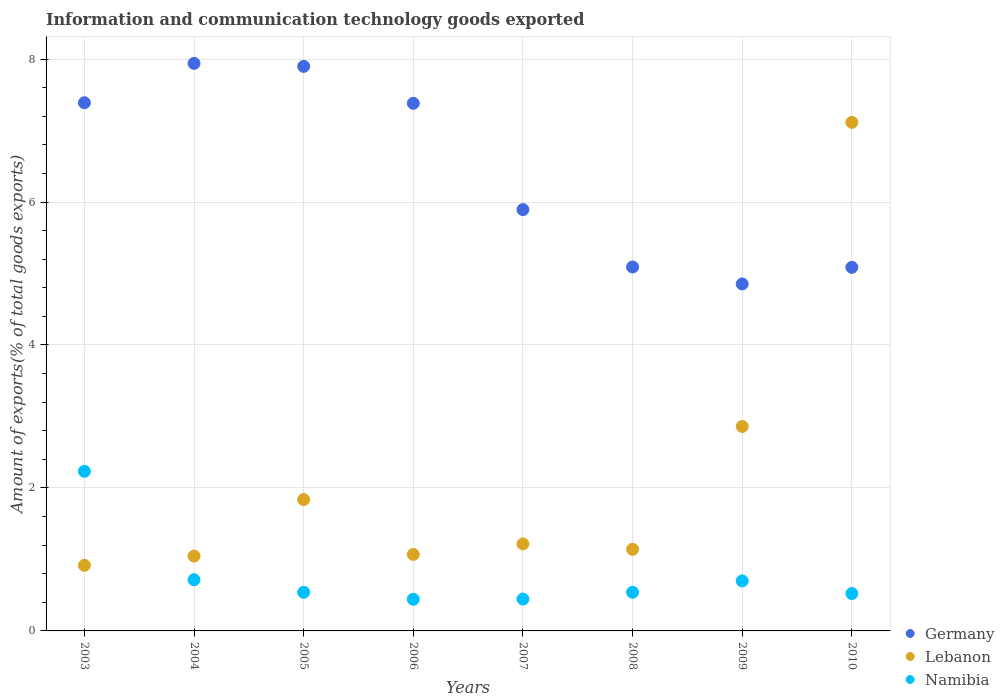What is the amount of goods exported in Germany in 2004?
Give a very brief answer. 7.94. Across all years, what is the maximum amount of goods exported in Lebanon?
Your response must be concise. 7.11. Across all years, what is the minimum amount of goods exported in Lebanon?
Ensure brevity in your answer.  0.92. What is the total amount of goods exported in Lebanon in the graph?
Offer a very short reply. 17.2. What is the difference between the amount of goods exported in Germany in 2004 and that in 2007?
Your answer should be very brief. 2.05. What is the difference between the amount of goods exported in Lebanon in 2006 and the amount of goods exported in Germany in 2005?
Your response must be concise. -6.83. What is the average amount of goods exported in Germany per year?
Keep it short and to the point. 6.44. In the year 2003, what is the difference between the amount of goods exported in Namibia and amount of goods exported in Germany?
Offer a very short reply. -5.16. What is the ratio of the amount of goods exported in Germany in 2004 to that in 2008?
Your answer should be very brief. 1.56. Is the difference between the amount of goods exported in Namibia in 2004 and 2007 greater than the difference between the amount of goods exported in Germany in 2004 and 2007?
Your response must be concise. No. What is the difference between the highest and the second highest amount of goods exported in Germany?
Your answer should be compact. 0.04. What is the difference between the highest and the lowest amount of goods exported in Namibia?
Offer a terse response. 1.79. Is the sum of the amount of goods exported in Lebanon in 2007 and 2010 greater than the maximum amount of goods exported in Germany across all years?
Make the answer very short. Yes. Is it the case that in every year, the sum of the amount of goods exported in Lebanon and amount of goods exported in Germany  is greater than the amount of goods exported in Namibia?
Your response must be concise. Yes. Does the amount of goods exported in Lebanon monotonically increase over the years?
Make the answer very short. No. Is the amount of goods exported in Germany strictly greater than the amount of goods exported in Namibia over the years?
Give a very brief answer. Yes. Is the amount of goods exported in Germany strictly less than the amount of goods exported in Namibia over the years?
Make the answer very short. No. How many years are there in the graph?
Offer a very short reply. 8. What is the difference between two consecutive major ticks on the Y-axis?
Offer a terse response. 2. Are the values on the major ticks of Y-axis written in scientific E-notation?
Your answer should be compact. No. Does the graph contain any zero values?
Give a very brief answer. No. Does the graph contain grids?
Your answer should be very brief. Yes. Where does the legend appear in the graph?
Give a very brief answer. Bottom right. How are the legend labels stacked?
Offer a terse response. Vertical. What is the title of the graph?
Your answer should be compact. Information and communication technology goods exported. Does "Belarus" appear as one of the legend labels in the graph?
Keep it short and to the point. No. What is the label or title of the Y-axis?
Offer a very short reply. Amount of exports(% of total goods exports). What is the Amount of exports(% of total goods exports) in Germany in 2003?
Your answer should be compact. 7.39. What is the Amount of exports(% of total goods exports) in Lebanon in 2003?
Your answer should be very brief. 0.92. What is the Amount of exports(% of total goods exports) of Namibia in 2003?
Keep it short and to the point. 2.23. What is the Amount of exports(% of total goods exports) of Germany in 2004?
Offer a terse response. 7.94. What is the Amount of exports(% of total goods exports) in Lebanon in 2004?
Your response must be concise. 1.05. What is the Amount of exports(% of total goods exports) of Namibia in 2004?
Ensure brevity in your answer.  0.72. What is the Amount of exports(% of total goods exports) in Germany in 2005?
Provide a succinct answer. 7.9. What is the Amount of exports(% of total goods exports) of Lebanon in 2005?
Your answer should be compact. 1.84. What is the Amount of exports(% of total goods exports) in Namibia in 2005?
Offer a very short reply. 0.54. What is the Amount of exports(% of total goods exports) of Germany in 2006?
Make the answer very short. 7.38. What is the Amount of exports(% of total goods exports) of Lebanon in 2006?
Offer a very short reply. 1.07. What is the Amount of exports(% of total goods exports) of Namibia in 2006?
Provide a succinct answer. 0.44. What is the Amount of exports(% of total goods exports) of Germany in 2007?
Keep it short and to the point. 5.89. What is the Amount of exports(% of total goods exports) in Lebanon in 2007?
Provide a short and direct response. 1.22. What is the Amount of exports(% of total goods exports) of Namibia in 2007?
Provide a succinct answer. 0.45. What is the Amount of exports(% of total goods exports) in Germany in 2008?
Offer a very short reply. 5.09. What is the Amount of exports(% of total goods exports) of Lebanon in 2008?
Offer a terse response. 1.14. What is the Amount of exports(% of total goods exports) in Namibia in 2008?
Provide a succinct answer. 0.54. What is the Amount of exports(% of total goods exports) of Germany in 2009?
Your answer should be compact. 4.85. What is the Amount of exports(% of total goods exports) in Lebanon in 2009?
Your response must be concise. 2.86. What is the Amount of exports(% of total goods exports) in Namibia in 2009?
Give a very brief answer. 0.7. What is the Amount of exports(% of total goods exports) in Germany in 2010?
Offer a very short reply. 5.09. What is the Amount of exports(% of total goods exports) in Lebanon in 2010?
Offer a very short reply. 7.11. What is the Amount of exports(% of total goods exports) in Namibia in 2010?
Your answer should be compact. 0.52. Across all years, what is the maximum Amount of exports(% of total goods exports) of Germany?
Offer a very short reply. 7.94. Across all years, what is the maximum Amount of exports(% of total goods exports) in Lebanon?
Keep it short and to the point. 7.11. Across all years, what is the maximum Amount of exports(% of total goods exports) of Namibia?
Offer a very short reply. 2.23. Across all years, what is the minimum Amount of exports(% of total goods exports) of Germany?
Your response must be concise. 4.85. Across all years, what is the minimum Amount of exports(% of total goods exports) of Lebanon?
Your answer should be compact. 0.92. Across all years, what is the minimum Amount of exports(% of total goods exports) in Namibia?
Your response must be concise. 0.44. What is the total Amount of exports(% of total goods exports) of Germany in the graph?
Your response must be concise. 51.53. What is the total Amount of exports(% of total goods exports) of Lebanon in the graph?
Give a very brief answer. 17.2. What is the total Amount of exports(% of total goods exports) in Namibia in the graph?
Your answer should be very brief. 6.14. What is the difference between the Amount of exports(% of total goods exports) in Germany in 2003 and that in 2004?
Your response must be concise. -0.55. What is the difference between the Amount of exports(% of total goods exports) in Lebanon in 2003 and that in 2004?
Your response must be concise. -0.13. What is the difference between the Amount of exports(% of total goods exports) in Namibia in 2003 and that in 2004?
Provide a succinct answer. 1.52. What is the difference between the Amount of exports(% of total goods exports) of Germany in 2003 and that in 2005?
Keep it short and to the point. -0.51. What is the difference between the Amount of exports(% of total goods exports) of Lebanon in 2003 and that in 2005?
Your response must be concise. -0.92. What is the difference between the Amount of exports(% of total goods exports) in Namibia in 2003 and that in 2005?
Your response must be concise. 1.69. What is the difference between the Amount of exports(% of total goods exports) of Germany in 2003 and that in 2006?
Make the answer very short. 0.01. What is the difference between the Amount of exports(% of total goods exports) of Lebanon in 2003 and that in 2006?
Your answer should be very brief. -0.15. What is the difference between the Amount of exports(% of total goods exports) in Namibia in 2003 and that in 2006?
Keep it short and to the point. 1.79. What is the difference between the Amount of exports(% of total goods exports) of Germany in 2003 and that in 2007?
Ensure brevity in your answer.  1.49. What is the difference between the Amount of exports(% of total goods exports) of Lebanon in 2003 and that in 2007?
Provide a succinct answer. -0.3. What is the difference between the Amount of exports(% of total goods exports) in Namibia in 2003 and that in 2007?
Your answer should be compact. 1.79. What is the difference between the Amount of exports(% of total goods exports) of Germany in 2003 and that in 2008?
Ensure brevity in your answer.  2.3. What is the difference between the Amount of exports(% of total goods exports) in Lebanon in 2003 and that in 2008?
Provide a short and direct response. -0.22. What is the difference between the Amount of exports(% of total goods exports) in Namibia in 2003 and that in 2008?
Your response must be concise. 1.69. What is the difference between the Amount of exports(% of total goods exports) in Germany in 2003 and that in 2009?
Make the answer very short. 2.53. What is the difference between the Amount of exports(% of total goods exports) in Lebanon in 2003 and that in 2009?
Offer a terse response. -1.94. What is the difference between the Amount of exports(% of total goods exports) of Namibia in 2003 and that in 2009?
Your answer should be compact. 1.53. What is the difference between the Amount of exports(% of total goods exports) of Germany in 2003 and that in 2010?
Provide a succinct answer. 2.3. What is the difference between the Amount of exports(% of total goods exports) of Lebanon in 2003 and that in 2010?
Provide a short and direct response. -6.2. What is the difference between the Amount of exports(% of total goods exports) in Namibia in 2003 and that in 2010?
Provide a succinct answer. 1.71. What is the difference between the Amount of exports(% of total goods exports) of Germany in 2004 and that in 2005?
Ensure brevity in your answer.  0.04. What is the difference between the Amount of exports(% of total goods exports) of Lebanon in 2004 and that in 2005?
Your answer should be compact. -0.79. What is the difference between the Amount of exports(% of total goods exports) of Namibia in 2004 and that in 2005?
Your answer should be compact. 0.18. What is the difference between the Amount of exports(% of total goods exports) of Germany in 2004 and that in 2006?
Your answer should be compact. 0.56. What is the difference between the Amount of exports(% of total goods exports) of Lebanon in 2004 and that in 2006?
Your answer should be compact. -0.02. What is the difference between the Amount of exports(% of total goods exports) in Namibia in 2004 and that in 2006?
Give a very brief answer. 0.27. What is the difference between the Amount of exports(% of total goods exports) of Germany in 2004 and that in 2007?
Ensure brevity in your answer.  2.05. What is the difference between the Amount of exports(% of total goods exports) of Lebanon in 2004 and that in 2007?
Make the answer very short. -0.17. What is the difference between the Amount of exports(% of total goods exports) in Namibia in 2004 and that in 2007?
Your response must be concise. 0.27. What is the difference between the Amount of exports(% of total goods exports) of Germany in 2004 and that in 2008?
Keep it short and to the point. 2.85. What is the difference between the Amount of exports(% of total goods exports) of Lebanon in 2004 and that in 2008?
Ensure brevity in your answer.  -0.09. What is the difference between the Amount of exports(% of total goods exports) in Namibia in 2004 and that in 2008?
Offer a terse response. 0.17. What is the difference between the Amount of exports(% of total goods exports) of Germany in 2004 and that in 2009?
Your response must be concise. 3.09. What is the difference between the Amount of exports(% of total goods exports) of Lebanon in 2004 and that in 2009?
Offer a very short reply. -1.81. What is the difference between the Amount of exports(% of total goods exports) in Namibia in 2004 and that in 2009?
Your answer should be compact. 0.02. What is the difference between the Amount of exports(% of total goods exports) of Germany in 2004 and that in 2010?
Your response must be concise. 2.85. What is the difference between the Amount of exports(% of total goods exports) in Lebanon in 2004 and that in 2010?
Make the answer very short. -6.07. What is the difference between the Amount of exports(% of total goods exports) in Namibia in 2004 and that in 2010?
Provide a succinct answer. 0.19. What is the difference between the Amount of exports(% of total goods exports) of Germany in 2005 and that in 2006?
Make the answer very short. 0.52. What is the difference between the Amount of exports(% of total goods exports) in Lebanon in 2005 and that in 2006?
Give a very brief answer. 0.77. What is the difference between the Amount of exports(% of total goods exports) of Namibia in 2005 and that in 2006?
Provide a succinct answer. 0.1. What is the difference between the Amount of exports(% of total goods exports) of Germany in 2005 and that in 2007?
Make the answer very short. 2. What is the difference between the Amount of exports(% of total goods exports) of Lebanon in 2005 and that in 2007?
Ensure brevity in your answer.  0.62. What is the difference between the Amount of exports(% of total goods exports) in Namibia in 2005 and that in 2007?
Your response must be concise. 0.09. What is the difference between the Amount of exports(% of total goods exports) of Germany in 2005 and that in 2008?
Ensure brevity in your answer.  2.81. What is the difference between the Amount of exports(% of total goods exports) of Lebanon in 2005 and that in 2008?
Provide a short and direct response. 0.7. What is the difference between the Amount of exports(% of total goods exports) in Namibia in 2005 and that in 2008?
Provide a short and direct response. -0. What is the difference between the Amount of exports(% of total goods exports) of Germany in 2005 and that in 2009?
Make the answer very short. 3.04. What is the difference between the Amount of exports(% of total goods exports) of Lebanon in 2005 and that in 2009?
Offer a very short reply. -1.02. What is the difference between the Amount of exports(% of total goods exports) of Namibia in 2005 and that in 2009?
Give a very brief answer. -0.16. What is the difference between the Amount of exports(% of total goods exports) of Germany in 2005 and that in 2010?
Your response must be concise. 2.81. What is the difference between the Amount of exports(% of total goods exports) in Lebanon in 2005 and that in 2010?
Make the answer very short. -5.28. What is the difference between the Amount of exports(% of total goods exports) of Namibia in 2005 and that in 2010?
Your response must be concise. 0.02. What is the difference between the Amount of exports(% of total goods exports) in Germany in 2006 and that in 2007?
Keep it short and to the point. 1.49. What is the difference between the Amount of exports(% of total goods exports) of Lebanon in 2006 and that in 2007?
Offer a terse response. -0.15. What is the difference between the Amount of exports(% of total goods exports) of Namibia in 2006 and that in 2007?
Provide a succinct answer. -0. What is the difference between the Amount of exports(% of total goods exports) of Germany in 2006 and that in 2008?
Provide a succinct answer. 2.29. What is the difference between the Amount of exports(% of total goods exports) in Lebanon in 2006 and that in 2008?
Provide a short and direct response. -0.07. What is the difference between the Amount of exports(% of total goods exports) of Namibia in 2006 and that in 2008?
Offer a terse response. -0.1. What is the difference between the Amount of exports(% of total goods exports) of Germany in 2006 and that in 2009?
Make the answer very short. 2.53. What is the difference between the Amount of exports(% of total goods exports) in Lebanon in 2006 and that in 2009?
Offer a terse response. -1.79. What is the difference between the Amount of exports(% of total goods exports) of Namibia in 2006 and that in 2009?
Provide a succinct answer. -0.26. What is the difference between the Amount of exports(% of total goods exports) of Germany in 2006 and that in 2010?
Your response must be concise. 2.29. What is the difference between the Amount of exports(% of total goods exports) in Lebanon in 2006 and that in 2010?
Ensure brevity in your answer.  -6.04. What is the difference between the Amount of exports(% of total goods exports) of Namibia in 2006 and that in 2010?
Make the answer very short. -0.08. What is the difference between the Amount of exports(% of total goods exports) in Germany in 2007 and that in 2008?
Your answer should be compact. 0.8. What is the difference between the Amount of exports(% of total goods exports) of Lebanon in 2007 and that in 2008?
Your response must be concise. 0.08. What is the difference between the Amount of exports(% of total goods exports) of Namibia in 2007 and that in 2008?
Offer a terse response. -0.1. What is the difference between the Amount of exports(% of total goods exports) in Lebanon in 2007 and that in 2009?
Offer a terse response. -1.64. What is the difference between the Amount of exports(% of total goods exports) in Namibia in 2007 and that in 2009?
Make the answer very short. -0.25. What is the difference between the Amount of exports(% of total goods exports) in Germany in 2007 and that in 2010?
Your answer should be very brief. 0.81. What is the difference between the Amount of exports(% of total goods exports) in Lebanon in 2007 and that in 2010?
Your response must be concise. -5.9. What is the difference between the Amount of exports(% of total goods exports) of Namibia in 2007 and that in 2010?
Your response must be concise. -0.08. What is the difference between the Amount of exports(% of total goods exports) in Germany in 2008 and that in 2009?
Your answer should be compact. 0.24. What is the difference between the Amount of exports(% of total goods exports) of Lebanon in 2008 and that in 2009?
Your response must be concise. -1.72. What is the difference between the Amount of exports(% of total goods exports) of Namibia in 2008 and that in 2009?
Give a very brief answer. -0.16. What is the difference between the Amount of exports(% of total goods exports) in Germany in 2008 and that in 2010?
Your answer should be very brief. 0. What is the difference between the Amount of exports(% of total goods exports) of Lebanon in 2008 and that in 2010?
Give a very brief answer. -5.97. What is the difference between the Amount of exports(% of total goods exports) of Namibia in 2008 and that in 2010?
Make the answer very short. 0.02. What is the difference between the Amount of exports(% of total goods exports) of Germany in 2009 and that in 2010?
Provide a short and direct response. -0.23. What is the difference between the Amount of exports(% of total goods exports) in Lebanon in 2009 and that in 2010?
Offer a very short reply. -4.25. What is the difference between the Amount of exports(% of total goods exports) of Namibia in 2009 and that in 2010?
Make the answer very short. 0.18. What is the difference between the Amount of exports(% of total goods exports) of Germany in 2003 and the Amount of exports(% of total goods exports) of Lebanon in 2004?
Your answer should be compact. 6.34. What is the difference between the Amount of exports(% of total goods exports) of Germany in 2003 and the Amount of exports(% of total goods exports) of Namibia in 2004?
Ensure brevity in your answer.  6.67. What is the difference between the Amount of exports(% of total goods exports) in Lebanon in 2003 and the Amount of exports(% of total goods exports) in Namibia in 2004?
Offer a terse response. 0.2. What is the difference between the Amount of exports(% of total goods exports) in Germany in 2003 and the Amount of exports(% of total goods exports) in Lebanon in 2005?
Your answer should be very brief. 5.55. What is the difference between the Amount of exports(% of total goods exports) of Germany in 2003 and the Amount of exports(% of total goods exports) of Namibia in 2005?
Your answer should be compact. 6.85. What is the difference between the Amount of exports(% of total goods exports) of Lebanon in 2003 and the Amount of exports(% of total goods exports) of Namibia in 2005?
Give a very brief answer. 0.38. What is the difference between the Amount of exports(% of total goods exports) in Germany in 2003 and the Amount of exports(% of total goods exports) in Lebanon in 2006?
Your answer should be very brief. 6.32. What is the difference between the Amount of exports(% of total goods exports) of Germany in 2003 and the Amount of exports(% of total goods exports) of Namibia in 2006?
Offer a very short reply. 6.95. What is the difference between the Amount of exports(% of total goods exports) in Lebanon in 2003 and the Amount of exports(% of total goods exports) in Namibia in 2006?
Keep it short and to the point. 0.47. What is the difference between the Amount of exports(% of total goods exports) in Germany in 2003 and the Amount of exports(% of total goods exports) in Lebanon in 2007?
Your response must be concise. 6.17. What is the difference between the Amount of exports(% of total goods exports) in Germany in 2003 and the Amount of exports(% of total goods exports) in Namibia in 2007?
Your response must be concise. 6.94. What is the difference between the Amount of exports(% of total goods exports) of Lebanon in 2003 and the Amount of exports(% of total goods exports) of Namibia in 2007?
Provide a short and direct response. 0.47. What is the difference between the Amount of exports(% of total goods exports) in Germany in 2003 and the Amount of exports(% of total goods exports) in Lebanon in 2008?
Your response must be concise. 6.25. What is the difference between the Amount of exports(% of total goods exports) in Germany in 2003 and the Amount of exports(% of total goods exports) in Namibia in 2008?
Provide a short and direct response. 6.85. What is the difference between the Amount of exports(% of total goods exports) of Lebanon in 2003 and the Amount of exports(% of total goods exports) of Namibia in 2008?
Give a very brief answer. 0.38. What is the difference between the Amount of exports(% of total goods exports) in Germany in 2003 and the Amount of exports(% of total goods exports) in Lebanon in 2009?
Offer a very short reply. 4.53. What is the difference between the Amount of exports(% of total goods exports) in Germany in 2003 and the Amount of exports(% of total goods exports) in Namibia in 2009?
Keep it short and to the point. 6.69. What is the difference between the Amount of exports(% of total goods exports) in Lebanon in 2003 and the Amount of exports(% of total goods exports) in Namibia in 2009?
Your response must be concise. 0.22. What is the difference between the Amount of exports(% of total goods exports) of Germany in 2003 and the Amount of exports(% of total goods exports) of Lebanon in 2010?
Your answer should be very brief. 0.27. What is the difference between the Amount of exports(% of total goods exports) in Germany in 2003 and the Amount of exports(% of total goods exports) in Namibia in 2010?
Give a very brief answer. 6.87. What is the difference between the Amount of exports(% of total goods exports) in Lebanon in 2003 and the Amount of exports(% of total goods exports) in Namibia in 2010?
Offer a very short reply. 0.39. What is the difference between the Amount of exports(% of total goods exports) of Germany in 2004 and the Amount of exports(% of total goods exports) of Lebanon in 2005?
Ensure brevity in your answer.  6.1. What is the difference between the Amount of exports(% of total goods exports) in Germany in 2004 and the Amount of exports(% of total goods exports) in Namibia in 2005?
Provide a short and direct response. 7.4. What is the difference between the Amount of exports(% of total goods exports) in Lebanon in 2004 and the Amount of exports(% of total goods exports) in Namibia in 2005?
Ensure brevity in your answer.  0.51. What is the difference between the Amount of exports(% of total goods exports) in Germany in 2004 and the Amount of exports(% of total goods exports) in Lebanon in 2006?
Ensure brevity in your answer.  6.87. What is the difference between the Amount of exports(% of total goods exports) in Germany in 2004 and the Amount of exports(% of total goods exports) in Namibia in 2006?
Make the answer very short. 7.5. What is the difference between the Amount of exports(% of total goods exports) of Lebanon in 2004 and the Amount of exports(% of total goods exports) of Namibia in 2006?
Your answer should be very brief. 0.6. What is the difference between the Amount of exports(% of total goods exports) of Germany in 2004 and the Amount of exports(% of total goods exports) of Lebanon in 2007?
Offer a very short reply. 6.72. What is the difference between the Amount of exports(% of total goods exports) in Germany in 2004 and the Amount of exports(% of total goods exports) in Namibia in 2007?
Provide a short and direct response. 7.49. What is the difference between the Amount of exports(% of total goods exports) in Lebanon in 2004 and the Amount of exports(% of total goods exports) in Namibia in 2007?
Offer a terse response. 0.6. What is the difference between the Amount of exports(% of total goods exports) of Germany in 2004 and the Amount of exports(% of total goods exports) of Lebanon in 2008?
Offer a very short reply. 6.8. What is the difference between the Amount of exports(% of total goods exports) of Germany in 2004 and the Amount of exports(% of total goods exports) of Namibia in 2008?
Your answer should be very brief. 7.4. What is the difference between the Amount of exports(% of total goods exports) in Lebanon in 2004 and the Amount of exports(% of total goods exports) in Namibia in 2008?
Provide a succinct answer. 0.51. What is the difference between the Amount of exports(% of total goods exports) of Germany in 2004 and the Amount of exports(% of total goods exports) of Lebanon in 2009?
Offer a terse response. 5.08. What is the difference between the Amount of exports(% of total goods exports) of Germany in 2004 and the Amount of exports(% of total goods exports) of Namibia in 2009?
Provide a short and direct response. 7.24. What is the difference between the Amount of exports(% of total goods exports) of Lebanon in 2004 and the Amount of exports(% of total goods exports) of Namibia in 2009?
Give a very brief answer. 0.35. What is the difference between the Amount of exports(% of total goods exports) of Germany in 2004 and the Amount of exports(% of total goods exports) of Lebanon in 2010?
Make the answer very short. 0.83. What is the difference between the Amount of exports(% of total goods exports) of Germany in 2004 and the Amount of exports(% of total goods exports) of Namibia in 2010?
Keep it short and to the point. 7.42. What is the difference between the Amount of exports(% of total goods exports) in Lebanon in 2004 and the Amount of exports(% of total goods exports) in Namibia in 2010?
Offer a very short reply. 0.52. What is the difference between the Amount of exports(% of total goods exports) in Germany in 2005 and the Amount of exports(% of total goods exports) in Lebanon in 2006?
Make the answer very short. 6.83. What is the difference between the Amount of exports(% of total goods exports) in Germany in 2005 and the Amount of exports(% of total goods exports) in Namibia in 2006?
Keep it short and to the point. 7.45. What is the difference between the Amount of exports(% of total goods exports) in Lebanon in 2005 and the Amount of exports(% of total goods exports) in Namibia in 2006?
Your answer should be very brief. 1.39. What is the difference between the Amount of exports(% of total goods exports) of Germany in 2005 and the Amount of exports(% of total goods exports) of Lebanon in 2007?
Your response must be concise. 6.68. What is the difference between the Amount of exports(% of total goods exports) of Germany in 2005 and the Amount of exports(% of total goods exports) of Namibia in 2007?
Offer a terse response. 7.45. What is the difference between the Amount of exports(% of total goods exports) in Lebanon in 2005 and the Amount of exports(% of total goods exports) in Namibia in 2007?
Make the answer very short. 1.39. What is the difference between the Amount of exports(% of total goods exports) of Germany in 2005 and the Amount of exports(% of total goods exports) of Lebanon in 2008?
Keep it short and to the point. 6.76. What is the difference between the Amount of exports(% of total goods exports) of Germany in 2005 and the Amount of exports(% of total goods exports) of Namibia in 2008?
Make the answer very short. 7.36. What is the difference between the Amount of exports(% of total goods exports) in Lebanon in 2005 and the Amount of exports(% of total goods exports) in Namibia in 2008?
Ensure brevity in your answer.  1.3. What is the difference between the Amount of exports(% of total goods exports) in Germany in 2005 and the Amount of exports(% of total goods exports) in Lebanon in 2009?
Keep it short and to the point. 5.04. What is the difference between the Amount of exports(% of total goods exports) of Germany in 2005 and the Amount of exports(% of total goods exports) of Namibia in 2009?
Make the answer very short. 7.2. What is the difference between the Amount of exports(% of total goods exports) of Lebanon in 2005 and the Amount of exports(% of total goods exports) of Namibia in 2009?
Your answer should be very brief. 1.14. What is the difference between the Amount of exports(% of total goods exports) in Germany in 2005 and the Amount of exports(% of total goods exports) in Lebanon in 2010?
Provide a short and direct response. 0.78. What is the difference between the Amount of exports(% of total goods exports) of Germany in 2005 and the Amount of exports(% of total goods exports) of Namibia in 2010?
Provide a succinct answer. 7.37. What is the difference between the Amount of exports(% of total goods exports) of Lebanon in 2005 and the Amount of exports(% of total goods exports) of Namibia in 2010?
Provide a succinct answer. 1.31. What is the difference between the Amount of exports(% of total goods exports) of Germany in 2006 and the Amount of exports(% of total goods exports) of Lebanon in 2007?
Provide a succinct answer. 6.16. What is the difference between the Amount of exports(% of total goods exports) of Germany in 2006 and the Amount of exports(% of total goods exports) of Namibia in 2007?
Ensure brevity in your answer.  6.94. What is the difference between the Amount of exports(% of total goods exports) of Lebanon in 2006 and the Amount of exports(% of total goods exports) of Namibia in 2007?
Give a very brief answer. 0.62. What is the difference between the Amount of exports(% of total goods exports) of Germany in 2006 and the Amount of exports(% of total goods exports) of Lebanon in 2008?
Offer a terse response. 6.24. What is the difference between the Amount of exports(% of total goods exports) of Germany in 2006 and the Amount of exports(% of total goods exports) of Namibia in 2008?
Offer a very short reply. 6.84. What is the difference between the Amount of exports(% of total goods exports) in Lebanon in 2006 and the Amount of exports(% of total goods exports) in Namibia in 2008?
Make the answer very short. 0.53. What is the difference between the Amount of exports(% of total goods exports) of Germany in 2006 and the Amount of exports(% of total goods exports) of Lebanon in 2009?
Your answer should be compact. 4.52. What is the difference between the Amount of exports(% of total goods exports) of Germany in 2006 and the Amount of exports(% of total goods exports) of Namibia in 2009?
Provide a short and direct response. 6.68. What is the difference between the Amount of exports(% of total goods exports) of Lebanon in 2006 and the Amount of exports(% of total goods exports) of Namibia in 2009?
Your answer should be very brief. 0.37. What is the difference between the Amount of exports(% of total goods exports) of Germany in 2006 and the Amount of exports(% of total goods exports) of Lebanon in 2010?
Give a very brief answer. 0.27. What is the difference between the Amount of exports(% of total goods exports) of Germany in 2006 and the Amount of exports(% of total goods exports) of Namibia in 2010?
Make the answer very short. 6.86. What is the difference between the Amount of exports(% of total goods exports) in Lebanon in 2006 and the Amount of exports(% of total goods exports) in Namibia in 2010?
Offer a very short reply. 0.55. What is the difference between the Amount of exports(% of total goods exports) of Germany in 2007 and the Amount of exports(% of total goods exports) of Lebanon in 2008?
Offer a terse response. 4.75. What is the difference between the Amount of exports(% of total goods exports) in Germany in 2007 and the Amount of exports(% of total goods exports) in Namibia in 2008?
Make the answer very short. 5.35. What is the difference between the Amount of exports(% of total goods exports) of Lebanon in 2007 and the Amount of exports(% of total goods exports) of Namibia in 2008?
Your answer should be compact. 0.68. What is the difference between the Amount of exports(% of total goods exports) in Germany in 2007 and the Amount of exports(% of total goods exports) in Lebanon in 2009?
Provide a succinct answer. 3.03. What is the difference between the Amount of exports(% of total goods exports) in Germany in 2007 and the Amount of exports(% of total goods exports) in Namibia in 2009?
Give a very brief answer. 5.19. What is the difference between the Amount of exports(% of total goods exports) in Lebanon in 2007 and the Amount of exports(% of total goods exports) in Namibia in 2009?
Your response must be concise. 0.52. What is the difference between the Amount of exports(% of total goods exports) of Germany in 2007 and the Amount of exports(% of total goods exports) of Lebanon in 2010?
Provide a succinct answer. -1.22. What is the difference between the Amount of exports(% of total goods exports) in Germany in 2007 and the Amount of exports(% of total goods exports) in Namibia in 2010?
Give a very brief answer. 5.37. What is the difference between the Amount of exports(% of total goods exports) in Lebanon in 2007 and the Amount of exports(% of total goods exports) in Namibia in 2010?
Offer a terse response. 0.69. What is the difference between the Amount of exports(% of total goods exports) in Germany in 2008 and the Amount of exports(% of total goods exports) in Lebanon in 2009?
Offer a terse response. 2.23. What is the difference between the Amount of exports(% of total goods exports) in Germany in 2008 and the Amount of exports(% of total goods exports) in Namibia in 2009?
Your answer should be compact. 4.39. What is the difference between the Amount of exports(% of total goods exports) of Lebanon in 2008 and the Amount of exports(% of total goods exports) of Namibia in 2009?
Give a very brief answer. 0.44. What is the difference between the Amount of exports(% of total goods exports) of Germany in 2008 and the Amount of exports(% of total goods exports) of Lebanon in 2010?
Give a very brief answer. -2.02. What is the difference between the Amount of exports(% of total goods exports) of Germany in 2008 and the Amount of exports(% of total goods exports) of Namibia in 2010?
Your answer should be compact. 4.57. What is the difference between the Amount of exports(% of total goods exports) of Lebanon in 2008 and the Amount of exports(% of total goods exports) of Namibia in 2010?
Your response must be concise. 0.62. What is the difference between the Amount of exports(% of total goods exports) of Germany in 2009 and the Amount of exports(% of total goods exports) of Lebanon in 2010?
Keep it short and to the point. -2.26. What is the difference between the Amount of exports(% of total goods exports) in Germany in 2009 and the Amount of exports(% of total goods exports) in Namibia in 2010?
Provide a short and direct response. 4.33. What is the difference between the Amount of exports(% of total goods exports) in Lebanon in 2009 and the Amount of exports(% of total goods exports) in Namibia in 2010?
Your response must be concise. 2.34. What is the average Amount of exports(% of total goods exports) of Germany per year?
Ensure brevity in your answer.  6.44. What is the average Amount of exports(% of total goods exports) in Lebanon per year?
Keep it short and to the point. 2.15. What is the average Amount of exports(% of total goods exports) of Namibia per year?
Your answer should be very brief. 0.77. In the year 2003, what is the difference between the Amount of exports(% of total goods exports) of Germany and Amount of exports(% of total goods exports) of Lebanon?
Provide a succinct answer. 6.47. In the year 2003, what is the difference between the Amount of exports(% of total goods exports) in Germany and Amount of exports(% of total goods exports) in Namibia?
Offer a very short reply. 5.16. In the year 2003, what is the difference between the Amount of exports(% of total goods exports) of Lebanon and Amount of exports(% of total goods exports) of Namibia?
Your answer should be very brief. -1.32. In the year 2004, what is the difference between the Amount of exports(% of total goods exports) in Germany and Amount of exports(% of total goods exports) in Lebanon?
Your answer should be very brief. 6.89. In the year 2004, what is the difference between the Amount of exports(% of total goods exports) in Germany and Amount of exports(% of total goods exports) in Namibia?
Offer a terse response. 7.22. In the year 2004, what is the difference between the Amount of exports(% of total goods exports) of Lebanon and Amount of exports(% of total goods exports) of Namibia?
Make the answer very short. 0.33. In the year 2005, what is the difference between the Amount of exports(% of total goods exports) of Germany and Amount of exports(% of total goods exports) of Lebanon?
Ensure brevity in your answer.  6.06. In the year 2005, what is the difference between the Amount of exports(% of total goods exports) of Germany and Amount of exports(% of total goods exports) of Namibia?
Make the answer very short. 7.36. In the year 2005, what is the difference between the Amount of exports(% of total goods exports) of Lebanon and Amount of exports(% of total goods exports) of Namibia?
Make the answer very short. 1.3. In the year 2006, what is the difference between the Amount of exports(% of total goods exports) in Germany and Amount of exports(% of total goods exports) in Lebanon?
Provide a succinct answer. 6.31. In the year 2006, what is the difference between the Amount of exports(% of total goods exports) in Germany and Amount of exports(% of total goods exports) in Namibia?
Make the answer very short. 6.94. In the year 2006, what is the difference between the Amount of exports(% of total goods exports) in Lebanon and Amount of exports(% of total goods exports) in Namibia?
Ensure brevity in your answer.  0.63. In the year 2007, what is the difference between the Amount of exports(% of total goods exports) in Germany and Amount of exports(% of total goods exports) in Lebanon?
Keep it short and to the point. 4.68. In the year 2007, what is the difference between the Amount of exports(% of total goods exports) of Germany and Amount of exports(% of total goods exports) of Namibia?
Keep it short and to the point. 5.45. In the year 2007, what is the difference between the Amount of exports(% of total goods exports) of Lebanon and Amount of exports(% of total goods exports) of Namibia?
Provide a short and direct response. 0.77. In the year 2008, what is the difference between the Amount of exports(% of total goods exports) of Germany and Amount of exports(% of total goods exports) of Lebanon?
Offer a very short reply. 3.95. In the year 2008, what is the difference between the Amount of exports(% of total goods exports) in Germany and Amount of exports(% of total goods exports) in Namibia?
Make the answer very short. 4.55. In the year 2008, what is the difference between the Amount of exports(% of total goods exports) of Lebanon and Amount of exports(% of total goods exports) of Namibia?
Give a very brief answer. 0.6. In the year 2009, what is the difference between the Amount of exports(% of total goods exports) in Germany and Amount of exports(% of total goods exports) in Lebanon?
Your answer should be very brief. 1.99. In the year 2009, what is the difference between the Amount of exports(% of total goods exports) of Germany and Amount of exports(% of total goods exports) of Namibia?
Keep it short and to the point. 4.15. In the year 2009, what is the difference between the Amount of exports(% of total goods exports) of Lebanon and Amount of exports(% of total goods exports) of Namibia?
Your answer should be very brief. 2.16. In the year 2010, what is the difference between the Amount of exports(% of total goods exports) in Germany and Amount of exports(% of total goods exports) in Lebanon?
Make the answer very short. -2.03. In the year 2010, what is the difference between the Amount of exports(% of total goods exports) in Germany and Amount of exports(% of total goods exports) in Namibia?
Offer a very short reply. 4.56. In the year 2010, what is the difference between the Amount of exports(% of total goods exports) of Lebanon and Amount of exports(% of total goods exports) of Namibia?
Ensure brevity in your answer.  6.59. What is the ratio of the Amount of exports(% of total goods exports) of Germany in 2003 to that in 2004?
Provide a succinct answer. 0.93. What is the ratio of the Amount of exports(% of total goods exports) of Lebanon in 2003 to that in 2004?
Your answer should be compact. 0.88. What is the ratio of the Amount of exports(% of total goods exports) in Namibia in 2003 to that in 2004?
Your response must be concise. 3.12. What is the ratio of the Amount of exports(% of total goods exports) of Germany in 2003 to that in 2005?
Ensure brevity in your answer.  0.94. What is the ratio of the Amount of exports(% of total goods exports) in Lebanon in 2003 to that in 2005?
Your answer should be compact. 0.5. What is the ratio of the Amount of exports(% of total goods exports) of Namibia in 2003 to that in 2005?
Your answer should be compact. 4.13. What is the ratio of the Amount of exports(% of total goods exports) of Germany in 2003 to that in 2006?
Offer a very short reply. 1. What is the ratio of the Amount of exports(% of total goods exports) of Lebanon in 2003 to that in 2006?
Ensure brevity in your answer.  0.86. What is the ratio of the Amount of exports(% of total goods exports) of Namibia in 2003 to that in 2006?
Offer a terse response. 5.04. What is the ratio of the Amount of exports(% of total goods exports) of Germany in 2003 to that in 2007?
Offer a terse response. 1.25. What is the ratio of the Amount of exports(% of total goods exports) in Lebanon in 2003 to that in 2007?
Provide a short and direct response. 0.75. What is the ratio of the Amount of exports(% of total goods exports) in Namibia in 2003 to that in 2007?
Offer a terse response. 5.01. What is the ratio of the Amount of exports(% of total goods exports) of Germany in 2003 to that in 2008?
Give a very brief answer. 1.45. What is the ratio of the Amount of exports(% of total goods exports) in Lebanon in 2003 to that in 2008?
Offer a very short reply. 0.8. What is the ratio of the Amount of exports(% of total goods exports) of Namibia in 2003 to that in 2008?
Give a very brief answer. 4.13. What is the ratio of the Amount of exports(% of total goods exports) in Germany in 2003 to that in 2009?
Make the answer very short. 1.52. What is the ratio of the Amount of exports(% of total goods exports) of Lebanon in 2003 to that in 2009?
Offer a terse response. 0.32. What is the ratio of the Amount of exports(% of total goods exports) of Namibia in 2003 to that in 2009?
Give a very brief answer. 3.19. What is the ratio of the Amount of exports(% of total goods exports) of Germany in 2003 to that in 2010?
Offer a very short reply. 1.45. What is the ratio of the Amount of exports(% of total goods exports) in Lebanon in 2003 to that in 2010?
Offer a very short reply. 0.13. What is the ratio of the Amount of exports(% of total goods exports) in Namibia in 2003 to that in 2010?
Offer a terse response. 4.27. What is the ratio of the Amount of exports(% of total goods exports) of Germany in 2004 to that in 2005?
Provide a short and direct response. 1.01. What is the ratio of the Amount of exports(% of total goods exports) of Lebanon in 2004 to that in 2005?
Provide a succinct answer. 0.57. What is the ratio of the Amount of exports(% of total goods exports) in Namibia in 2004 to that in 2005?
Provide a short and direct response. 1.32. What is the ratio of the Amount of exports(% of total goods exports) in Germany in 2004 to that in 2006?
Your response must be concise. 1.08. What is the ratio of the Amount of exports(% of total goods exports) of Lebanon in 2004 to that in 2006?
Make the answer very short. 0.98. What is the ratio of the Amount of exports(% of total goods exports) in Namibia in 2004 to that in 2006?
Provide a succinct answer. 1.62. What is the ratio of the Amount of exports(% of total goods exports) of Germany in 2004 to that in 2007?
Give a very brief answer. 1.35. What is the ratio of the Amount of exports(% of total goods exports) in Lebanon in 2004 to that in 2007?
Give a very brief answer. 0.86. What is the ratio of the Amount of exports(% of total goods exports) of Namibia in 2004 to that in 2007?
Your answer should be very brief. 1.61. What is the ratio of the Amount of exports(% of total goods exports) of Germany in 2004 to that in 2008?
Your answer should be very brief. 1.56. What is the ratio of the Amount of exports(% of total goods exports) in Lebanon in 2004 to that in 2008?
Keep it short and to the point. 0.92. What is the ratio of the Amount of exports(% of total goods exports) in Namibia in 2004 to that in 2008?
Give a very brief answer. 1.32. What is the ratio of the Amount of exports(% of total goods exports) in Germany in 2004 to that in 2009?
Your answer should be compact. 1.64. What is the ratio of the Amount of exports(% of total goods exports) of Lebanon in 2004 to that in 2009?
Provide a short and direct response. 0.37. What is the ratio of the Amount of exports(% of total goods exports) in Namibia in 2004 to that in 2009?
Provide a short and direct response. 1.02. What is the ratio of the Amount of exports(% of total goods exports) in Germany in 2004 to that in 2010?
Provide a short and direct response. 1.56. What is the ratio of the Amount of exports(% of total goods exports) in Lebanon in 2004 to that in 2010?
Keep it short and to the point. 0.15. What is the ratio of the Amount of exports(% of total goods exports) of Namibia in 2004 to that in 2010?
Give a very brief answer. 1.37. What is the ratio of the Amount of exports(% of total goods exports) of Germany in 2005 to that in 2006?
Your answer should be very brief. 1.07. What is the ratio of the Amount of exports(% of total goods exports) of Lebanon in 2005 to that in 2006?
Your response must be concise. 1.72. What is the ratio of the Amount of exports(% of total goods exports) of Namibia in 2005 to that in 2006?
Provide a succinct answer. 1.22. What is the ratio of the Amount of exports(% of total goods exports) of Germany in 2005 to that in 2007?
Your answer should be very brief. 1.34. What is the ratio of the Amount of exports(% of total goods exports) in Lebanon in 2005 to that in 2007?
Ensure brevity in your answer.  1.51. What is the ratio of the Amount of exports(% of total goods exports) of Namibia in 2005 to that in 2007?
Offer a very short reply. 1.21. What is the ratio of the Amount of exports(% of total goods exports) in Germany in 2005 to that in 2008?
Make the answer very short. 1.55. What is the ratio of the Amount of exports(% of total goods exports) in Lebanon in 2005 to that in 2008?
Your response must be concise. 1.61. What is the ratio of the Amount of exports(% of total goods exports) in Namibia in 2005 to that in 2008?
Give a very brief answer. 1. What is the ratio of the Amount of exports(% of total goods exports) in Germany in 2005 to that in 2009?
Provide a short and direct response. 1.63. What is the ratio of the Amount of exports(% of total goods exports) in Lebanon in 2005 to that in 2009?
Ensure brevity in your answer.  0.64. What is the ratio of the Amount of exports(% of total goods exports) in Namibia in 2005 to that in 2009?
Ensure brevity in your answer.  0.77. What is the ratio of the Amount of exports(% of total goods exports) in Germany in 2005 to that in 2010?
Offer a very short reply. 1.55. What is the ratio of the Amount of exports(% of total goods exports) in Lebanon in 2005 to that in 2010?
Provide a succinct answer. 0.26. What is the ratio of the Amount of exports(% of total goods exports) in Namibia in 2005 to that in 2010?
Give a very brief answer. 1.03. What is the ratio of the Amount of exports(% of total goods exports) of Germany in 2006 to that in 2007?
Ensure brevity in your answer.  1.25. What is the ratio of the Amount of exports(% of total goods exports) of Lebanon in 2006 to that in 2007?
Make the answer very short. 0.88. What is the ratio of the Amount of exports(% of total goods exports) in Namibia in 2006 to that in 2007?
Offer a terse response. 0.99. What is the ratio of the Amount of exports(% of total goods exports) of Germany in 2006 to that in 2008?
Keep it short and to the point. 1.45. What is the ratio of the Amount of exports(% of total goods exports) of Lebanon in 2006 to that in 2008?
Your answer should be compact. 0.94. What is the ratio of the Amount of exports(% of total goods exports) in Namibia in 2006 to that in 2008?
Provide a short and direct response. 0.82. What is the ratio of the Amount of exports(% of total goods exports) in Germany in 2006 to that in 2009?
Ensure brevity in your answer.  1.52. What is the ratio of the Amount of exports(% of total goods exports) in Lebanon in 2006 to that in 2009?
Offer a terse response. 0.37. What is the ratio of the Amount of exports(% of total goods exports) of Namibia in 2006 to that in 2009?
Keep it short and to the point. 0.63. What is the ratio of the Amount of exports(% of total goods exports) of Germany in 2006 to that in 2010?
Your answer should be very brief. 1.45. What is the ratio of the Amount of exports(% of total goods exports) of Lebanon in 2006 to that in 2010?
Your answer should be very brief. 0.15. What is the ratio of the Amount of exports(% of total goods exports) in Namibia in 2006 to that in 2010?
Provide a short and direct response. 0.85. What is the ratio of the Amount of exports(% of total goods exports) in Germany in 2007 to that in 2008?
Provide a succinct answer. 1.16. What is the ratio of the Amount of exports(% of total goods exports) of Lebanon in 2007 to that in 2008?
Offer a terse response. 1.07. What is the ratio of the Amount of exports(% of total goods exports) of Namibia in 2007 to that in 2008?
Keep it short and to the point. 0.82. What is the ratio of the Amount of exports(% of total goods exports) in Germany in 2007 to that in 2009?
Make the answer very short. 1.21. What is the ratio of the Amount of exports(% of total goods exports) in Lebanon in 2007 to that in 2009?
Make the answer very short. 0.43. What is the ratio of the Amount of exports(% of total goods exports) of Namibia in 2007 to that in 2009?
Your response must be concise. 0.64. What is the ratio of the Amount of exports(% of total goods exports) of Germany in 2007 to that in 2010?
Keep it short and to the point. 1.16. What is the ratio of the Amount of exports(% of total goods exports) in Lebanon in 2007 to that in 2010?
Ensure brevity in your answer.  0.17. What is the ratio of the Amount of exports(% of total goods exports) of Namibia in 2007 to that in 2010?
Your answer should be very brief. 0.85. What is the ratio of the Amount of exports(% of total goods exports) of Germany in 2008 to that in 2009?
Keep it short and to the point. 1.05. What is the ratio of the Amount of exports(% of total goods exports) of Lebanon in 2008 to that in 2009?
Offer a terse response. 0.4. What is the ratio of the Amount of exports(% of total goods exports) of Namibia in 2008 to that in 2009?
Provide a short and direct response. 0.77. What is the ratio of the Amount of exports(% of total goods exports) in Lebanon in 2008 to that in 2010?
Your response must be concise. 0.16. What is the ratio of the Amount of exports(% of total goods exports) of Namibia in 2008 to that in 2010?
Your answer should be very brief. 1.03. What is the ratio of the Amount of exports(% of total goods exports) of Germany in 2009 to that in 2010?
Your answer should be compact. 0.95. What is the ratio of the Amount of exports(% of total goods exports) of Lebanon in 2009 to that in 2010?
Offer a terse response. 0.4. What is the ratio of the Amount of exports(% of total goods exports) in Namibia in 2009 to that in 2010?
Give a very brief answer. 1.34. What is the difference between the highest and the second highest Amount of exports(% of total goods exports) of Germany?
Provide a short and direct response. 0.04. What is the difference between the highest and the second highest Amount of exports(% of total goods exports) in Lebanon?
Provide a short and direct response. 4.25. What is the difference between the highest and the second highest Amount of exports(% of total goods exports) of Namibia?
Make the answer very short. 1.52. What is the difference between the highest and the lowest Amount of exports(% of total goods exports) in Germany?
Make the answer very short. 3.09. What is the difference between the highest and the lowest Amount of exports(% of total goods exports) of Lebanon?
Offer a terse response. 6.2. What is the difference between the highest and the lowest Amount of exports(% of total goods exports) in Namibia?
Your response must be concise. 1.79. 